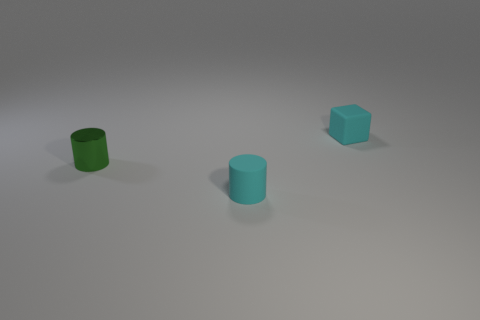Add 2 green cylinders. How many objects exist? 5 Subtract all blocks. How many objects are left? 2 Subtract all large red spheres. Subtract all rubber cylinders. How many objects are left? 2 Add 3 small green metal things. How many small green metal things are left? 4 Add 3 small blue metallic blocks. How many small blue metallic blocks exist? 3 Subtract 0 red balls. How many objects are left? 3 